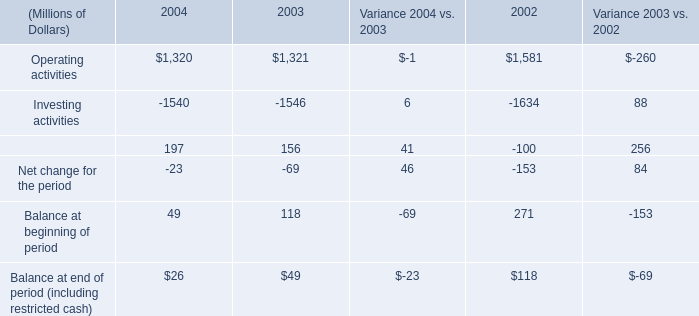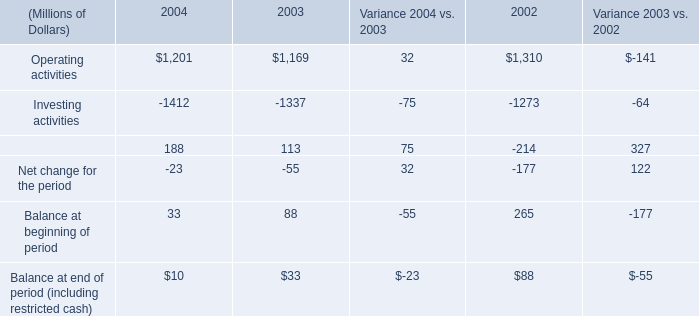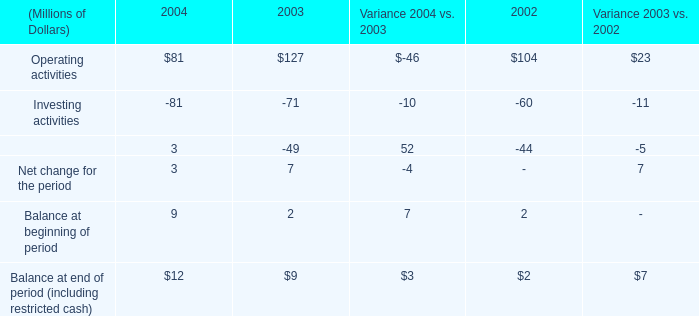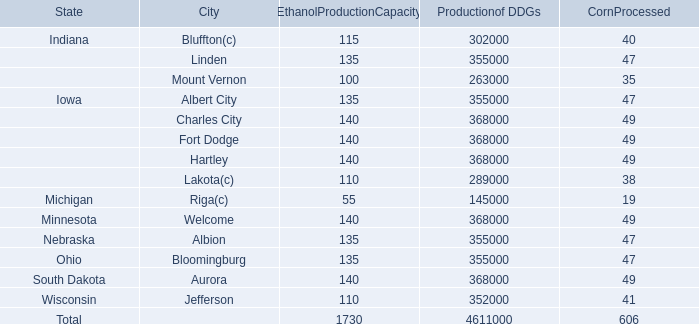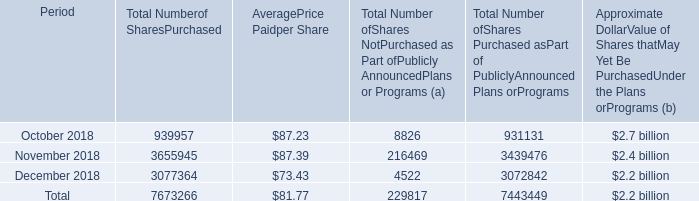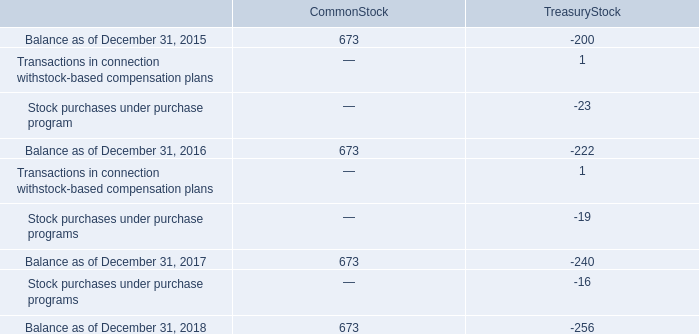What's the sum of Operating activities of 2004, Ohio of Productionof DDGs, and Nebraska of Productionof DDGs ? 
Computations: ((1201.0 + 355000.0) + 355000.0)
Answer: 711201.0. 